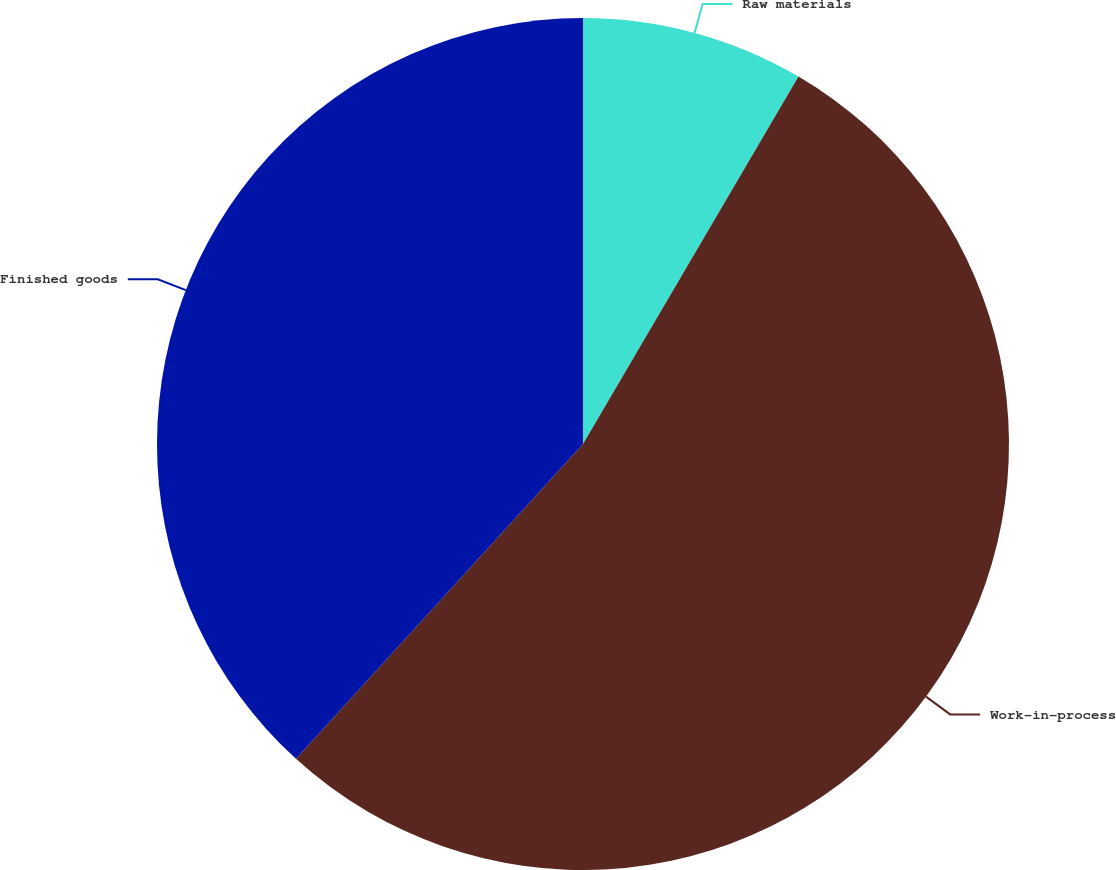<chart> <loc_0><loc_0><loc_500><loc_500><pie_chart><fcel>Raw materials<fcel>Work-in-process<fcel>Finished goods<nl><fcel>8.44%<fcel>53.32%<fcel>38.23%<nl></chart> 